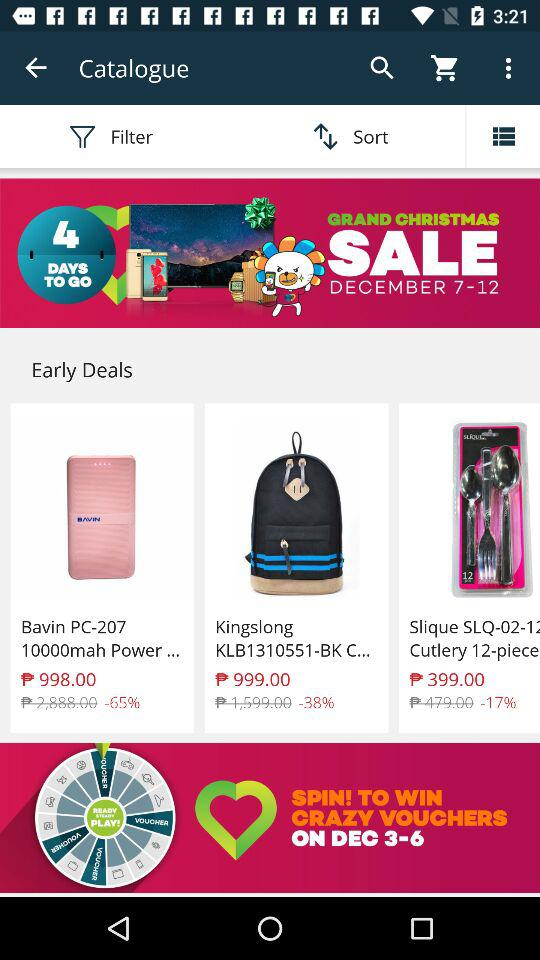How many items are on sale?
Answer the question using a single word or phrase. 3 